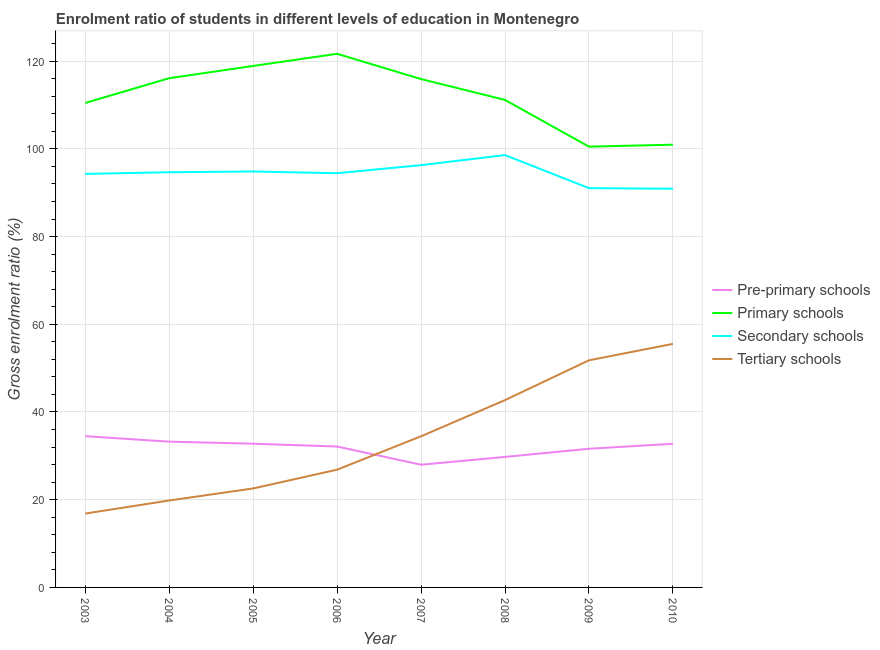How many different coloured lines are there?
Give a very brief answer. 4. Is the number of lines equal to the number of legend labels?
Your answer should be compact. Yes. What is the gross enrolment ratio in secondary schools in 2005?
Give a very brief answer. 94.84. Across all years, what is the maximum gross enrolment ratio in primary schools?
Keep it short and to the point. 121.67. Across all years, what is the minimum gross enrolment ratio in pre-primary schools?
Keep it short and to the point. 27.98. What is the total gross enrolment ratio in tertiary schools in the graph?
Offer a terse response. 270.57. What is the difference between the gross enrolment ratio in secondary schools in 2006 and that in 2007?
Provide a short and direct response. -1.85. What is the difference between the gross enrolment ratio in tertiary schools in 2009 and the gross enrolment ratio in secondary schools in 2003?
Your answer should be compact. -42.5. What is the average gross enrolment ratio in pre-primary schools per year?
Give a very brief answer. 31.84. In the year 2006, what is the difference between the gross enrolment ratio in tertiary schools and gross enrolment ratio in pre-primary schools?
Your answer should be compact. -5.28. In how many years, is the gross enrolment ratio in pre-primary schools greater than 108 %?
Your answer should be very brief. 0. What is the ratio of the gross enrolment ratio in primary schools in 2004 to that in 2005?
Give a very brief answer. 0.98. Is the difference between the gross enrolment ratio in pre-primary schools in 2003 and 2010 greater than the difference between the gross enrolment ratio in secondary schools in 2003 and 2010?
Your answer should be very brief. No. What is the difference between the highest and the second highest gross enrolment ratio in tertiary schools?
Your response must be concise. 3.75. What is the difference between the highest and the lowest gross enrolment ratio in primary schools?
Ensure brevity in your answer.  21.16. Is the sum of the gross enrolment ratio in tertiary schools in 2007 and 2010 greater than the maximum gross enrolment ratio in secondary schools across all years?
Keep it short and to the point. No. Does the gross enrolment ratio in pre-primary schools monotonically increase over the years?
Offer a terse response. No. Is the gross enrolment ratio in primary schools strictly less than the gross enrolment ratio in tertiary schools over the years?
Make the answer very short. No. How many lines are there?
Provide a short and direct response. 4. How many years are there in the graph?
Your answer should be compact. 8. Are the values on the major ticks of Y-axis written in scientific E-notation?
Your response must be concise. No. Does the graph contain grids?
Offer a very short reply. Yes. Where does the legend appear in the graph?
Your answer should be very brief. Center right. How many legend labels are there?
Ensure brevity in your answer.  4. What is the title of the graph?
Provide a succinct answer. Enrolment ratio of students in different levels of education in Montenegro. Does "France" appear as one of the legend labels in the graph?
Your answer should be very brief. No. What is the label or title of the X-axis?
Your answer should be very brief. Year. What is the Gross enrolment ratio (%) in Pre-primary schools in 2003?
Offer a very short reply. 34.48. What is the Gross enrolment ratio (%) of Primary schools in 2003?
Keep it short and to the point. 110.46. What is the Gross enrolment ratio (%) of Secondary schools in 2003?
Your answer should be compact. 94.29. What is the Gross enrolment ratio (%) of Tertiary schools in 2003?
Your response must be concise. 16.84. What is the Gross enrolment ratio (%) of Pre-primary schools in 2004?
Your answer should be very brief. 33.24. What is the Gross enrolment ratio (%) in Primary schools in 2004?
Ensure brevity in your answer.  116.11. What is the Gross enrolment ratio (%) of Secondary schools in 2004?
Keep it short and to the point. 94.66. What is the Gross enrolment ratio (%) of Tertiary schools in 2004?
Ensure brevity in your answer.  19.82. What is the Gross enrolment ratio (%) in Pre-primary schools in 2005?
Offer a very short reply. 32.77. What is the Gross enrolment ratio (%) of Primary schools in 2005?
Keep it short and to the point. 118.9. What is the Gross enrolment ratio (%) in Secondary schools in 2005?
Your answer should be very brief. 94.84. What is the Gross enrolment ratio (%) of Tertiary schools in 2005?
Your answer should be very brief. 22.57. What is the Gross enrolment ratio (%) in Pre-primary schools in 2006?
Keep it short and to the point. 32.13. What is the Gross enrolment ratio (%) in Primary schools in 2006?
Provide a succinct answer. 121.67. What is the Gross enrolment ratio (%) of Secondary schools in 2006?
Your answer should be very brief. 94.44. What is the Gross enrolment ratio (%) of Tertiary schools in 2006?
Your answer should be compact. 26.85. What is the Gross enrolment ratio (%) in Pre-primary schools in 2007?
Offer a very short reply. 27.98. What is the Gross enrolment ratio (%) in Primary schools in 2007?
Keep it short and to the point. 115.91. What is the Gross enrolment ratio (%) in Secondary schools in 2007?
Provide a succinct answer. 96.29. What is the Gross enrolment ratio (%) of Tertiary schools in 2007?
Your answer should be very brief. 34.46. What is the Gross enrolment ratio (%) of Pre-primary schools in 2008?
Ensure brevity in your answer.  29.76. What is the Gross enrolment ratio (%) of Primary schools in 2008?
Make the answer very short. 111.16. What is the Gross enrolment ratio (%) of Secondary schools in 2008?
Keep it short and to the point. 98.57. What is the Gross enrolment ratio (%) in Tertiary schools in 2008?
Your answer should be compact. 42.71. What is the Gross enrolment ratio (%) in Pre-primary schools in 2009?
Provide a short and direct response. 31.62. What is the Gross enrolment ratio (%) in Primary schools in 2009?
Make the answer very short. 100.5. What is the Gross enrolment ratio (%) of Secondary schools in 2009?
Give a very brief answer. 91.04. What is the Gross enrolment ratio (%) in Tertiary schools in 2009?
Give a very brief answer. 51.79. What is the Gross enrolment ratio (%) of Pre-primary schools in 2010?
Your response must be concise. 32.75. What is the Gross enrolment ratio (%) of Primary schools in 2010?
Provide a short and direct response. 100.95. What is the Gross enrolment ratio (%) of Secondary schools in 2010?
Offer a very short reply. 90.9. What is the Gross enrolment ratio (%) in Tertiary schools in 2010?
Offer a very short reply. 55.53. Across all years, what is the maximum Gross enrolment ratio (%) in Pre-primary schools?
Give a very brief answer. 34.48. Across all years, what is the maximum Gross enrolment ratio (%) in Primary schools?
Make the answer very short. 121.67. Across all years, what is the maximum Gross enrolment ratio (%) of Secondary schools?
Offer a terse response. 98.57. Across all years, what is the maximum Gross enrolment ratio (%) in Tertiary schools?
Offer a very short reply. 55.53. Across all years, what is the minimum Gross enrolment ratio (%) in Pre-primary schools?
Offer a very short reply. 27.98. Across all years, what is the minimum Gross enrolment ratio (%) of Primary schools?
Your response must be concise. 100.5. Across all years, what is the minimum Gross enrolment ratio (%) of Secondary schools?
Your response must be concise. 90.9. Across all years, what is the minimum Gross enrolment ratio (%) in Tertiary schools?
Your response must be concise. 16.84. What is the total Gross enrolment ratio (%) in Pre-primary schools in the graph?
Your answer should be compact. 254.72. What is the total Gross enrolment ratio (%) of Primary schools in the graph?
Your answer should be compact. 895.66. What is the total Gross enrolment ratio (%) in Secondary schools in the graph?
Offer a very short reply. 755.04. What is the total Gross enrolment ratio (%) of Tertiary schools in the graph?
Keep it short and to the point. 270.57. What is the difference between the Gross enrolment ratio (%) in Pre-primary schools in 2003 and that in 2004?
Your response must be concise. 1.25. What is the difference between the Gross enrolment ratio (%) in Primary schools in 2003 and that in 2004?
Your response must be concise. -5.64. What is the difference between the Gross enrolment ratio (%) in Secondary schools in 2003 and that in 2004?
Ensure brevity in your answer.  -0.38. What is the difference between the Gross enrolment ratio (%) of Tertiary schools in 2003 and that in 2004?
Your answer should be compact. -2.98. What is the difference between the Gross enrolment ratio (%) of Pre-primary schools in 2003 and that in 2005?
Your answer should be compact. 1.71. What is the difference between the Gross enrolment ratio (%) of Primary schools in 2003 and that in 2005?
Your answer should be compact. -8.44. What is the difference between the Gross enrolment ratio (%) of Secondary schools in 2003 and that in 2005?
Your answer should be very brief. -0.55. What is the difference between the Gross enrolment ratio (%) in Tertiary schools in 2003 and that in 2005?
Your answer should be very brief. -5.73. What is the difference between the Gross enrolment ratio (%) of Pre-primary schools in 2003 and that in 2006?
Ensure brevity in your answer.  2.36. What is the difference between the Gross enrolment ratio (%) in Primary schools in 2003 and that in 2006?
Provide a succinct answer. -11.2. What is the difference between the Gross enrolment ratio (%) in Secondary schools in 2003 and that in 2006?
Offer a terse response. -0.15. What is the difference between the Gross enrolment ratio (%) of Tertiary schools in 2003 and that in 2006?
Your answer should be very brief. -10.01. What is the difference between the Gross enrolment ratio (%) of Pre-primary schools in 2003 and that in 2007?
Provide a short and direct response. 6.51. What is the difference between the Gross enrolment ratio (%) of Primary schools in 2003 and that in 2007?
Provide a short and direct response. -5.45. What is the difference between the Gross enrolment ratio (%) of Secondary schools in 2003 and that in 2007?
Keep it short and to the point. -2. What is the difference between the Gross enrolment ratio (%) of Tertiary schools in 2003 and that in 2007?
Provide a short and direct response. -17.62. What is the difference between the Gross enrolment ratio (%) of Pre-primary schools in 2003 and that in 2008?
Your answer should be very brief. 4.73. What is the difference between the Gross enrolment ratio (%) in Primary schools in 2003 and that in 2008?
Ensure brevity in your answer.  -0.69. What is the difference between the Gross enrolment ratio (%) of Secondary schools in 2003 and that in 2008?
Keep it short and to the point. -4.28. What is the difference between the Gross enrolment ratio (%) in Tertiary schools in 2003 and that in 2008?
Your answer should be very brief. -25.87. What is the difference between the Gross enrolment ratio (%) of Pre-primary schools in 2003 and that in 2009?
Offer a terse response. 2.87. What is the difference between the Gross enrolment ratio (%) in Primary schools in 2003 and that in 2009?
Ensure brevity in your answer.  9.96. What is the difference between the Gross enrolment ratio (%) in Secondary schools in 2003 and that in 2009?
Your answer should be compact. 3.25. What is the difference between the Gross enrolment ratio (%) in Tertiary schools in 2003 and that in 2009?
Provide a succinct answer. -34.94. What is the difference between the Gross enrolment ratio (%) in Pre-primary schools in 2003 and that in 2010?
Make the answer very short. 1.73. What is the difference between the Gross enrolment ratio (%) of Primary schools in 2003 and that in 2010?
Give a very brief answer. 9.52. What is the difference between the Gross enrolment ratio (%) of Secondary schools in 2003 and that in 2010?
Offer a terse response. 3.39. What is the difference between the Gross enrolment ratio (%) in Tertiary schools in 2003 and that in 2010?
Your answer should be very brief. -38.69. What is the difference between the Gross enrolment ratio (%) in Pre-primary schools in 2004 and that in 2005?
Your response must be concise. 0.47. What is the difference between the Gross enrolment ratio (%) of Primary schools in 2004 and that in 2005?
Provide a succinct answer. -2.8. What is the difference between the Gross enrolment ratio (%) in Secondary schools in 2004 and that in 2005?
Give a very brief answer. -0.18. What is the difference between the Gross enrolment ratio (%) in Tertiary schools in 2004 and that in 2005?
Your response must be concise. -2.75. What is the difference between the Gross enrolment ratio (%) of Pre-primary schools in 2004 and that in 2006?
Offer a very short reply. 1.11. What is the difference between the Gross enrolment ratio (%) of Primary schools in 2004 and that in 2006?
Ensure brevity in your answer.  -5.56. What is the difference between the Gross enrolment ratio (%) in Secondary schools in 2004 and that in 2006?
Your answer should be very brief. 0.22. What is the difference between the Gross enrolment ratio (%) in Tertiary schools in 2004 and that in 2006?
Give a very brief answer. -7.03. What is the difference between the Gross enrolment ratio (%) in Pre-primary schools in 2004 and that in 2007?
Provide a short and direct response. 5.26. What is the difference between the Gross enrolment ratio (%) in Primary schools in 2004 and that in 2007?
Offer a very short reply. 0.19. What is the difference between the Gross enrolment ratio (%) of Secondary schools in 2004 and that in 2007?
Make the answer very short. -1.62. What is the difference between the Gross enrolment ratio (%) of Tertiary schools in 2004 and that in 2007?
Keep it short and to the point. -14.64. What is the difference between the Gross enrolment ratio (%) in Pre-primary schools in 2004 and that in 2008?
Your answer should be compact. 3.48. What is the difference between the Gross enrolment ratio (%) in Primary schools in 2004 and that in 2008?
Keep it short and to the point. 4.95. What is the difference between the Gross enrolment ratio (%) of Secondary schools in 2004 and that in 2008?
Keep it short and to the point. -3.91. What is the difference between the Gross enrolment ratio (%) in Tertiary schools in 2004 and that in 2008?
Your answer should be very brief. -22.89. What is the difference between the Gross enrolment ratio (%) in Pre-primary schools in 2004 and that in 2009?
Your answer should be compact. 1.62. What is the difference between the Gross enrolment ratio (%) of Primary schools in 2004 and that in 2009?
Provide a short and direct response. 15.6. What is the difference between the Gross enrolment ratio (%) in Secondary schools in 2004 and that in 2009?
Keep it short and to the point. 3.62. What is the difference between the Gross enrolment ratio (%) in Tertiary schools in 2004 and that in 2009?
Your answer should be very brief. -31.97. What is the difference between the Gross enrolment ratio (%) of Pre-primary schools in 2004 and that in 2010?
Offer a terse response. 0.49. What is the difference between the Gross enrolment ratio (%) in Primary schools in 2004 and that in 2010?
Offer a terse response. 15.16. What is the difference between the Gross enrolment ratio (%) of Secondary schools in 2004 and that in 2010?
Your response must be concise. 3.76. What is the difference between the Gross enrolment ratio (%) in Tertiary schools in 2004 and that in 2010?
Provide a succinct answer. -35.71. What is the difference between the Gross enrolment ratio (%) of Pre-primary schools in 2005 and that in 2006?
Provide a short and direct response. 0.64. What is the difference between the Gross enrolment ratio (%) of Primary schools in 2005 and that in 2006?
Offer a very short reply. -2.76. What is the difference between the Gross enrolment ratio (%) of Secondary schools in 2005 and that in 2006?
Make the answer very short. 0.4. What is the difference between the Gross enrolment ratio (%) in Tertiary schools in 2005 and that in 2006?
Make the answer very short. -4.28. What is the difference between the Gross enrolment ratio (%) in Pre-primary schools in 2005 and that in 2007?
Provide a short and direct response. 4.79. What is the difference between the Gross enrolment ratio (%) in Primary schools in 2005 and that in 2007?
Give a very brief answer. 2.99. What is the difference between the Gross enrolment ratio (%) of Secondary schools in 2005 and that in 2007?
Make the answer very short. -1.45. What is the difference between the Gross enrolment ratio (%) of Tertiary schools in 2005 and that in 2007?
Provide a succinct answer. -11.89. What is the difference between the Gross enrolment ratio (%) of Pre-primary schools in 2005 and that in 2008?
Your answer should be compact. 3.01. What is the difference between the Gross enrolment ratio (%) in Primary schools in 2005 and that in 2008?
Provide a succinct answer. 7.75. What is the difference between the Gross enrolment ratio (%) of Secondary schools in 2005 and that in 2008?
Your answer should be very brief. -3.73. What is the difference between the Gross enrolment ratio (%) of Tertiary schools in 2005 and that in 2008?
Ensure brevity in your answer.  -20.14. What is the difference between the Gross enrolment ratio (%) of Pre-primary schools in 2005 and that in 2009?
Provide a succinct answer. 1.15. What is the difference between the Gross enrolment ratio (%) of Primary schools in 2005 and that in 2009?
Your answer should be compact. 18.4. What is the difference between the Gross enrolment ratio (%) of Secondary schools in 2005 and that in 2009?
Ensure brevity in your answer.  3.8. What is the difference between the Gross enrolment ratio (%) in Tertiary schools in 2005 and that in 2009?
Offer a very short reply. -29.22. What is the difference between the Gross enrolment ratio (%) in Pre-primary schools in 2005 and that in 2010?
Your answer should be very brief. 0.02. What is the difference between the Gross enrolment ratio (%) in Primary schools in 2005 and that in 2010?
Your answer should be compact. 17.96. What is the difference between the Gross enrolment ratio (%) in Secondary schools in 2005 and that in 2010?
Keep it short and to the point. 3.94. What is the difference between the Gross enrolment ratio (%) of Tertiary schools in 2005 and that in 2010?
Your answer should be compact. -32.96. What is the difference between the Gross enrolment ratio (%) in Pre-primary schools in 2006 and that in 2007?
Provide a succinct answer. 4.15. What is the difference between the Gross enrolment ratio (%) in Primary schools in 2006 and that in 2007?
Offer a very short reply. 5.76. What is the difference between the Gross enrolment ratio (%) in Secondary schools in 2006 and that in 2007?
Offer a terse response. -1.85. What is the difference between the Gross enrolment ratio (%) of Tertiary schools in 2006 and that in 2007?
Provide a short and direct response. -7.62. What is the difference between the Gross enrolment ratio (%) of Pre-primary schools in 2006 and that in 2008?
Offer a terse response. 2.37. What is the difference between the Gross enrolment ratio (%) of Primary schools in 2006 and that in 2008?
Provide a succinct answer. 10.51. What is the difference between the Gross enrolment ratio (%) of Secondary schools in 2006 and that in 2008?
Offer a terse response. -4.13. What is the difference between the Gross enrolment ratio (%) in Tertiary schools in 2006 and that in 2008?
Keep it short and to the point. -15.86. What is the difference between the Gross enrolment ratio (%) in Pre-primary schools in 2006 and that in 2009?
Your answer should be very brief. 0.51. What is the difference between the Gross enrolment ratio (%) of Primary schools in 2006 and that in 2009?
Provide a short and direct response. 21.16. What is the difference between the Gross enrolment ratio (%) of Secondary schools in 2006 and that in 2009?
Your response must be concise. 3.4. What is the difference between the Gross enrolment ratio (%) in Tertiary schools in 2006 and that in 2009?
Offer a very short reply. -24.94. What is the difference between the Gross enrolment ratio (%) in Pre-primary schools in 2006 and that in 2010?
Your response must be concise. -0.62. What is the difference between the Gross enrolment ratio (%) in Primary schools in 2006 and that in 2010?
Give a very brief answer. 20.72. What is the difference between the Gross enrolment ratio (%) in Secondary schools in 2006 and that in 2010?
Provide a succinct answer. 3.54. What is the difference between the Gross enrolment ratio (%) in Tertiary schools in 2006 and that in 2010?
Your answer should be compact. -28.68. What is the difference between the Gross enrolment ratio (%) in Pre-primary schools in 2007 and that in 2008?
Make the answer very short. -1.78. What is the difference between the Gross enrolment ratio (%) in Primary schools in 2007 and that in 2008?
Your answer should be compact. 4.76. What is the difference between the Gross enrolment ratio (%) of Secondary schools in 2007 and that in 2008?
Offer a terse response. -2.28. What is the difference between the Gross enrolment ratio (%) in Tertiary schools in 2007 and that in 2008?
Your answer should be very brief. -8.25. What is the difference between the Gross enrolment ratio (%) of Pre-primary schools in 2007 and that in 2009?
Offer a terse response. -3.64. What is the difference between the Gross enrolment ratio (%) of Primary schools in 2007 and that in 2009?
Offer a very short reply. 15.41. What is the difference between the Gross enrolment ratio (%) of Secondary schools in 2007 and that in 2009?
Your answer should be very brief. 5.25. What is the difference between the Gross enrolment ratio (%) of Tertiary schools in 2007 and that in 2009?
Keep it short and to the point. -17.32. What is the difference between the Gross enrolment ratio (%) in Pre-primary schools in 2007 and that in 2010?
Offer a very short reply. -4.77. What is the difference between the Gross enrolment ratio (%) in Primary schools in 2007 and that in 2010?
Your response must be concise. 14.96. What is the difference between the Gross enrolment ratio (%) of Secondary schools in 2007 and that in 2010?
Your answer should be very brief. 5.39. What is the difference between the Gross enrolment ratio (%) in Tertiary schools in 2007 and that in 2010?
Ensure brevity in your answer.  -21.07. What is the difference between the Gross enrolment ratio (%) in Pre-primary schools in 2008 and that in 2009?
Ensure brevity in your answer.  -1.86. What is the difference between the Gross enrolment ratio (%) of Primary schools in 2008 and that in 2009?
Provide a succinct answer. 10.65. What is the difference between the Gross enrolment ratio (%) in Secondary schools in 2008 and that in 2009?
Your answer should be compact. 7.53. What is the difference between the Gross enrolment ratio (%) of Tertiary schools in 2008 and that in 2009?
Make the answer very short. -9.08. What is the difference between the Gross enrolment ratio (%) of Pre-primary schools in 2008 and that in 2010?
Offer a terse response. -2.99. What is the difference between the Gross enrolment ratio (%) of Primary schools in 2008 and that in 2010?
Your answer should be very brief. 10.21. What is the difference between the Gross enrolment ratio (%) of Secondary schools in 2008 and that in 2010?
Offer a terse response. 7.67. What is the difference between the Gross enrolment ratio (%) of Tertiary schools in 2008 and that in 2010?
Your response must be concise. -12.82. What is the difference between the Gross enrolment ratio (%) in Pre-primary schools in 2009 and that in 2010?
Your answer should be compact. -1.13. What is the difference between the Gross enrolment ratio (%) in Primary schools in 2009 and that in 2010?
Keep it short and to the point. -0.44. What is the difference between the Gross enrolment ratio (%) of Secondary schools in 2009 and that in 2010?
Provide a succinct answer. 0.14. What is the difference between the Gross enrolment ratio (%) of Tertiary schools in 2009 and that in 2010?
Your answer should be compact. -3.75. What is the difference between the Gross enrolment ratio (%) of Pre-primary schools in 2003 and the Gross enrolment ratio (%) of Primary schools in 2004?
Give a very brief answer. -81.62. What is the difference between the Gross enrolment ratio (%) of Pre-primary schools in 2003 and the Gross enrolment ratio (%) of Secondary schools in 2004?
Provide a succinct answer. -60.18. What is the difference between the Gross enrolment ratio (%) in Pre-primary schools in 2003 and the Gross enrolment ratio (%) in Tertiary schools in 2004?
Give a very brief answer. 14.67. What is the difference between the Gross enrolment ratio (%) of Primary schools in 2003 and the Gross enrolment ratio (%) of Secondary schools in 2004?
Offer a terse response. 15.8. What is the difference between the Gross enrolment ratio (%) of Primary schools in 2003 and the Gross enrolment ratio (%) of Tertiary schools in 2004?
Provide a short and direct response. 90.65. What is the difference between the Gross enrolment ratio (%) in Secondary schools in 2003 and the Gross enrolment ratio (%) in Tertiary schools in 2004?
Your response must be concise. 74.47. What is the difference between the Gross enrolment ratio (%) in Pre-primary schools in 2003 and the Gross enrolment ratio (%) in Primary schools in 2005?
Provide a short and direct response. -84.42. What is the difference between the Gross enrolment ratio (%) in Pre-primary schools in 2003 and the Gross enrolment ratio (%) in Secondary schools in 2005?
Make the answer very short. -60.36. What is the difference between the Gross enrolment ratio (%) in Pre-primary schools in 2003 and the Gross enrolment ratio (%) in Tertiary schools in 2005?
Your answer should be very brief. 11.91. What is the difference between the Gross enrolment ratio (%) of Primary schools in 2003 and the Gross enrolment ratio (%) of Secondary schools in 2005?
Provide a succinct answer. 15.62. What is the difference between the Gross enrolment ratio (%) of Primary schools in 2003 and the Gross enrolment ratio (%) of Tertiary schools in 2005?
Provide a succinct answer. 87.89. What is the difference between the Gross enrolment ratio (%) of Secondary schools in 2003 and the Gross enrolment ratio (%) of Tertiary schools in 2005?
Provide a short and direct response. 71.72. What is the difference between the Gross enrolment ratio (%) in Pre-primary schools in 2003 and the Gross enrolment ratio (%) in Primary schools in 2006?
Offer a very short reply. -87.18. What is the difference between the Gross enrolment ratio (%) in Pre-primary schools in 2003 and the Gross enrolment ratio (%) in Secondary schools in 2006?
Your answer should be very brief. -59.96. What is the difference between the Gross enrolment ratio (%) of Pre-primary schools in 2003 and the Gross enrolment ratio (%) of Tertiary schools in 2006?
Your answer should be compact. 7.64. What is the difference between the Gross enrolment ratio (%) in Primary schools in 2003 and the Gross enrolment ratio (%) in Secondary schools in 2006?
Offer a terse response. 16.02. What is the difference between the Gross enrolment ratio (%) of Primary schools in 2003 and the Gross enrolment ratio (%) of Tertiary schools in 2006?
Your answer should be very brief. 83.62. What is the difference between the Gross enrolment ratio (%) of Secondary schools in 2003 and the Gross enrolment ratio (%) of Tertiary schools in 2006?
Offer a terse response. 67.44. What is the difference between the Gross enrolment ratio (%) in Pre-primary schools in 2003 and the Gross enrolment ratio (%) in Primary schools in 2007?
Provide a short and direct response. -81.43. What is the difference between the Gross enrolment ratio (%) of Pre-primary schools in 2003 and the Gross enrolment ratio (%) of Secondary schools in 2007?
Provide a short and direct response. -61.8. What is the difference between the Gross enrolment ratio (%) of Pre-primary schools in 2003 and the Gross enrolment ratio (%) of Tertiary schools in 2007?
Your answer should be very brief. 0.02. What is the difference between the Gross enrolment ratio (%) in Primary schools in 2003 and the Gross enrolment ratio (%) in Secondary schools in 2007?
Offer a very short reply. 14.18. What is the difference between the Gross enrolment ratio (%) in Primary schools in 2003 and the Gross enrolment ratio (%) in Tertiary schools in 2007?
Provide a succinct answer. 76. What is the difference between the Gross enrolment ratio (%) of Secondary schools in 2003 and the Gross enrolment ratio (%) of Tertiary schools in 2007?
Make the answer very short. 59.83. What is the difference between the Gross enrolment ratio (%) of Pre-primary schools in 2003 and the Gross enrolment ratio (%) of Primary schools in 2008?
Make the answer very short. -76.67. What is the difference between the Gross enrolment ratio (%) in Pre-primary schools in 2003 and the Gross enrolment ratio (%) in Secondary schools in 2008?
Provide a short and direct response. -64.09. What is the difference between the Gross enrolment ratio (%) in Pre-primary schools in 2003 and the Gross enrolment ratio (%) in Tertiary schools in 2008?
Provide a succinct answer. -8.23. What is the difference between the Gross enrolment ratio (%) of Primary schools in 2003 and the Gross enrolment ratio (%) of Secondary schools in 2008?
Make the answer very short. 11.89. What is the difference between the Gross enrolment ratio (%) in Primary schools in 2003 and the Gross enrolment ratio (%) in Tertiary schools in 2008?
Provide a short and direct response. 67.75. What is the difference between the Gross enrolment ratio (%) in Secondary schools in 2003 and the Gross enrolment ratio (%) in Tertiary schools in 2008?
Your response must be concise. 51.58. What is the difference between the Gross enrolment ratio (%) in Pre-primary schools in 2003 and the Gross enrolment ratio (%) in Primary schools in 2009?
Make the answer very short. -66.02. What is the difference between the Gross enrolment ratio (%) in Pre-primary schools in 2003 and the Gross enrolment ratio (%) in Secondary schools in 2009?
Offer a terse response. -56.56. What is the difference between the Gross enrolment ratio (%) in Pre-primary schools in 2003 and the Gross enrolment ratio (%) in Tertiary schools in 2009?
Your response must be concise. -17.3. What is the difference between the Gross enrolment ratio (%) of Primary schools in 2003 and the Gross enrolment ratio (%) of Secondary schools in 2009?
Your response must be concise. 19.42. What is the difference between the Gross enrolment ratio (%) in Primary schools in 2003 and the Gross enrolment ratio (%) in Tertiary schools in 2009?
Your answer should be very brief. 58.68. What is the difference between the Gross enrolment ratio (%) of Secondary schools in 2003 and the Gross enrolment ratio (%) of Tertiary schools in 2009?
Offer a very short reply. 42.5. What is the difference between the Gross enrolment ratio (%) in Pre-primary schools in 2003 and the Gross enrolment ratio (%) in Primary schools in 2010?
Keep it short and to the point. -66.46. What is the difference between the Gross enrolment ratio (%) in Pre-primary schools in 2003 and the Gross enrolment ratio (%) in Secondary schools in 2010?
Give a very brief answer. -56.42. What is the difference between the Gross enrolment ratio (%) of Pre-primary schools in 2003 and the Gross enrolment ratio (%) of Tertiary schools in 2010?
Ensure brevity in your answer.  -21.05. What is the difference between the Gross enrolment ratio (%) in Primary schools in 2003 and the Gross enrolment ratio (%) in Secondary schools in 2010?
Your response must be concise. 19.56. What is the difference between the Gross enrolment ratio (%) of Primary schools in 2003 and the Gross enrolment ratio (%) of Tertiary schools in 2010?
Provide a succinct answer. 54.93. What is the difference between the Gross enrolment ratio (%) of Secondary schools in 2003 and the Gross enrolment ratio (%) of Tertiary schools in 2010?
Your answer should be compact. 38.76. What is the difference between the Gross enrolment ratio (%) of Pre-primary schools in 2004 and the Gross enrolment ratio (%) of Primary schools in 2005?
Provide a short and direct response. -85.67. What is the difference between the Gross enrolment ratio (%) of Pre-primary schools in 2004 and the Gross enrolment ratio (%) of Secondary schools in 2005?
Ensure brevity in your answer.  -61.6. What is the difference between the Gross enrolment ratio (%) in Pre-primary schools in 2004 and the Gross enrolment ratio (%) in Tertiary schools in 2005?
Keep it short and to the point. 10.67. What is the difference between the Gross enrolment ratio (%) in Primary schools in 2004 and the Gross enrolment ratio (%) in Secondary schools in 2005?
Offer a very short reply. 21.27. What is the difference between the Gross enrolment ratio (%) of Primary schools in 2004 and the Gross enrolment ratio (%) of Tertiary schools in 2005?
Ensure brevity in your answer.  93.54. What is the difference between the Gross enrolment ratio (%) of Secondary schools in 2004 and the Gross enrolment ratio (%) of Tertiary schools in 2005?
Provide a short and direct response. 72.09. What is the difference between the Gross enrolment ratio (%) in Pre-primary schools in 2004 and the Gross enrolment ratio (%) in Primary schools in 2006?
Provide a succinct answer. -88.43. What is the difference between the Gross enrolment ratio (%) of Pre-primary schools in 2004 and the Gross enrolment ratio (%) of Secondary schools in 2006?
Offer a very short reply. -61.2. What is the difference between the Gross enrolment ratio (%) in Pre-primary schools in 2004 and the Gross enrolment ratio (%) in Tertiary schools in 2006?
Provide a succinct answer. 6.39. What is the difference between the Gross enrolment ratio (%) in Primary schools in 2004 and the Gross enrolment ratio (%) in Secondary schools in 2006?
Provide a succinct answer. 21.66. What is the difference between the Gross enrolment ratio (%) in Primary schools in 2004 and the Gross enrolment ratio (%) in Tertiary schools in 2006?
Offer a very short reply. 89.26. What is the difference between the Gross enrolment ratio (%) in Secondary schools in 2004 and the Gross enrolment ratio (%) in Tertiary schools in 2006?
Keep it short and to the point. 67.82. What is the difference between the Gross enrolment ratio (%) in Pre-primary schools in 2004 and the Gross enrolment ratio (%) in Primary schools in 2007?
Keep it short and to the point. -82.67. What is the difference between the Gross enrolment ratio (%) of Pre-primary schools in 2004 and the Gross enrolment ratio (%) of Secondary schools in 2007?
Ensure brevity in your answer.  -63.05. What is the difference between the Gross enrolment ratio (%) of Pre-primary schools in 2004 and the Gross enrolment ratio (%) of Tertiary schools in 2007?
Your answer should be very brief. -1.22. What is the difference between the Gross enrolment ratio (%) in Primary schools in 2004 and the Gross enrolment ratio (%) in Secondary schools in 2007?
Provide a short and direct response. 19.82. What is the difference between the Gross enrolment ratio (%) in Primary schools in 2004 and the Gross enrolment ratio (%) in Tertiary schools in 2007?
Provide a succinct answer. 81.64. What is the difference between the Gross enrolment ratio (%) of Secondary schools in 2004 and the Gross enrolment ratio (%) of Tertiary schools in 2007?
Offer a terse response. 60.2. What is the difference between the Gross enrolment ratio (%) of Pre-primary schools in 2004 and the Gross enrolment ratio (%) of Primary schools in 2008?
Your response must be concise. -77.92. What is the difference between the Gross enrolment ratio (%) of Pre-primary schools in 2004 and the Gross enrolment ratio (%) of Secondary schools in 2008?
Your answer should be compact. -65.33. What is the difference between the Gross enrolment ratio (%) of Pre-primary schools in 2004 and the Gross enrolment ratio (%) of Tertiary schools in 2008?
Offer a very short reply. -9.47. What is the difference between the Gross enrolment ratio (%) in Primary schools in 2004 and the Gross enrolment ratio (%) in Secondary schools in 2008?
Keep it short and to the point. 17.53. What is the difference between the Gross enrolment ratio (%) in Primary schools in 2004 and the Gross enrolment ratio (%) in Tertiary schools in 2008?
Offer a terse response. 73.4. What is the difference between the Gross enrolment ratio (%) in Secondary schools in 2004 and the Gross enrolment ratio (%) in Tertiary schools in 2008?
Ensure brevity in your answer.  51.95. What is the difference between the Gross enrolment ratio (%) in Pre-primary schools in 2004 and the Gross enrolment ratio (%) in Primary schools in 2009?
Your response must be concise. -67.26. What is the difference between the Gross enrolment ratio (%) in Pre-primary schools in 2004 and the Gross enrolment ratio (%) in Secondary schools in 2009?
Provide a succinct answer. -57.8. What is the difference between the Gross enrolment ratio (%) of Pre-primary schools in 2004 and the Gross enrolment ratio (%) of Tertiary schools in 2009?
Provide a short and direct response. -18.55. What is the difference between the Gross enrolment ratio (%) in Primary schools in 2004 and the Gross enrolment ratio (%) in Secondary schools in 2009?
Offer a very short reply. 25.07. What is the difference between the Gross enrolment ratio (%) in Primary schools in 2004 and the Gross enrolment ratio (%) in Tertiary schools in 2009?
Make the answer very short. 64.32. What is the difference between the Gross enrolment ratio (%) of Secondary schools in 2004 and the Gross enrolment ratio (%) of Tertiary schools in 2009?
Provide a succinct answer. 42.88. What is the difference between the Gross enrolment ratio (%) of Pre-primary schools in 2004 and the Gross enrolment ratio (%) of Primary schools in 2010?
Provide a short and direct response. -67.71. What is the difference between the Gross enrolment ratio (%) in Pre-primary schools in 2004 and the Gross enrolment ratio (%) in Secondary schools in 2010?
Keep it short and to the point. -57.66. What is the difference between the Gross enrolment ratio (%) in Pre-primary schools in 2004 and the Gross enrolment ratio (%) in Tertiary schools in 2010?
Your answer should be compact. -22.29. What is the difference between the Gross enrolment ratio (%) in Primary schools in 2004 and the Gross enrolment ratio (%) in Secondary schools in 2010?
Give a very brief answer. 25.2. What is the difference between the Gross enrolment ratio (%) in Primary schools in 2004 and the Gross enrolment ratio (%) in Tertiary schools in 2010?
Your answer should be compact. 60.57. What is the difference between the Gross enrolment ratio (%) of Secondary schools in 2004 and the Gross enrolment ratio (%) of Tertiary schools in 2010?
Keep it short and to the point. 39.13. What is the difference between the Gross enrolment ratio (%) of Pre-primary schools in 2005 and the Gross enrolment ratio (%) of Primary schools in 2006?
Offer a very short reply. -88.9. What is the difference between the Gross enrolment ratio (%) in Pre-primary schools in 2005 and the Gross enrolment ratio (%) in Secondary schools in 2006?
Your answer should be very brief. -61.67. What is the difference between the Gross enrolment ratio (%) of Pre-primary schools in 2005 and the Gross enrolment ratio (%) of Tertiary schools in 2006?
Provide a short and direct response. 5.92. What is the difference between the Gross enrolment ratio (%) in Primary schools in 2005 and the Gross enrolment ratio (%) in Secondary schools in 2006?
Provide a short and direct response. 24.46. What is the difference between the Gross enrolment ratio (%) of Primary schools in 2005 and the Gross enrolment ratio (%) of Tertiary schools in 2006?
Your answer should be compact. 92.06. What is the difference between the Gross enrolment ratio (%) in Secondary schools in 2005 and the Gross enrolment ratio (%) in Tertiary schools in 2006?
Provide a short and direct response. 67.99. What is the difference between the Gross enrolment ratio (%) in Pre-primary schools in 2005 and the Gross enrolment ratio (%) in Primary schools in 2007?
Offer a very short reply. -83.14. What is the difference between the Gross enrolment ratio (%) of Pre-primary schools in 2005 and the Gross enrolment ratio (%) of Secondary schools in 2007?
Ensure brevity in your answer.  -63.52. What is the difference between the Gross enrolment ratio (%) of Pre-primary schools in 2005 and the Gross enrolment ratio (%) of Tertiary schools in 2007?
Provide a succinct answer. -1.69. What is the difference between the Gross enrolment ratio (%) in Primary schools in 2005 and the Gross enrolment ratio (%) in Secondary schools in 2007?
Offer a terse response. 22.62. What is the difference between the Gross enrolment ratio (%) in Primary schools in 2005 and the Gross enrolment ratio (%) in Tertiary schools in 2007?
Provide a short and direct response. 84.44. What is the difference between the Gross enrolment ratio (%) in Secondary schools in 2005 and the Gross enrolment ratio (%) in Tertiary schools in 2007?
Provide a short and direct response. 60.38. What is the difference between the Gross enrolment ratio (%) in Pre-primary schools in 2005 and the Gross enrolment ratio (%) in Primary schools in 2008?
Offer a terse response. -78.38. What is the difference between the Gross enrolment ratio (%) of Pre-primary schools in 2005 and the Gross enrolment ratio (%) of Secondary schools in 2008?
Make the answer very short. -65.8. What is the difference between the Gross enrolment ratio (%) in Pre-primary schools in 2005 and the Gross enrolment ratio (%) in Tertiary schools in 2008?
Keep it short and to the point. -9.94. What is the difference between the Gross enrolment ratio (%) in Primary schools in 2005 and the Gross enrolment ratio (%) in Secondary schools in 2008?
Your response must be concise. 20.33. What is the difference between the Gross enrolment ratio (%) of Primary schools in 2005 and the Gross enrolment ratio (%) of Tertiary schools in 2008?
Offer a very short reply. 76.19. What is the difference between the Gross enrolment ratio (%) of Secondary schools in 2005 and the Gross enrolment ratio (%) of Tertiary schools in 2008?
Offer a terse response. 52.13. What is the difference between the Gross enrolment ratio (%) of Pre-primary schools in 2005 and the Gross enrolment ratio (%) of Primary schools in 2009?
Keep it short and to the point. -67.73. What is the difference between the Gross enrolment ratio (%) of Pre-primary schools in 2005 and the Gross enrolment ratio (%) of Secondary schools in 2009?
Give a very brief answer. -58.27. What is the difference between the Gross enrolment ratio (%) of Pre-primary schools in 2005 and the Gross enrolment ratio (%) of Tertiary schools in 2009?
Give a very brief answer. -19.01. What is the difference between the Gross enrolment ratio (%) of Primary schools in 2005 and the Gross enrolment ratio (%) of Secondary schools in 2009?
Make the answer very short. 27.86. What is the difference between the Gross enrolment ratio (%) of Primary schools in 2005 and the Gross enrolment ratio (%) of Tertiary schools in 2009?
Your answer should be compact. 67.12. What is the difference between the Gross enrolment ratio (%) in Secondary schools in 2005 and the Gross enrolment ratio (%) in Tertiary schools in 2009?
Give a very brief answer. 43.06. What is the difference between the Gross enrolment ratio (%) of Pre-primary schools in 2005 and the Gross enrolment ratio (%) of Primary schools in 2010?
Your answer should be compact. -68.18. What is the difference between the Gross enrolment ratio (%) of Pre-primary schools in 2005 and the Gross enrolment ratio (%) of Secondary schools in 2010?
Provide a short and direct response. -58.13. What is the difference between the Gross enrolment ratio (%) of Pre-primary schools in 2005 and the Gross enrolment ratio (%) of Tertiary schools in 2010?
Make the answer very short. -22.76. What is the difference between the Gross enrolment ratio (%) of Primary schools in 2005 and the Gross enrolment ratio (%) of Secondary schools in 2010?
Ensure brevity in your answer.  28. What is the difference between the Gross enrolment ratio (%) of Primary schools in 2005 and the Gross enrolment ratio (%) of Tertiary schools in 2010?
Give a very brief answer. 63.37. What is the difference between the Gross enrolment ratio (%) in Secondary schools in 2005 and the Gross enrolment ratio (%) in Tertiary schools in 2010?
Your answer should be compact. 39.31. What is the difference between the Gross enrolment ratio (%) in Pre-primary schools in 2006 and the Gross enrolment ratio (%) in Primary schools in 2007?
Your response must be concise. -83.78. What is the difference between the Gross enrolment ratio (%) of Pre-primary schools in 2006 and the Gross enrolment ratio (%) of Secondary schools in 2007?
Ensure brevity in your answer.  -64.16. What is the difference between the Gross enrolment ratio (%) in Pre-primary schools in 2006 and the Gross enrolment ratio (%) in Tertiary schools in 2007?
Make the answer very short. -2.34. What is the difference between the Gross enrolment ratio (%) in Primary schools in 2006 and the Gross enrolment ratio (%) in Secondary schools in 2007?
Your response must be concise. 25.38. What is the difference between the Gross enrolment ratio (%) of Primary schools in 2006 and the Gross enrolment ratio (%) of Tertiary schools in 2007?
Provide a short and direct response. 87.21. What is the difference between the Gross enrolment ratio (%) in Secondary schools in 2006 and the Gross enrolment ratio (%) in Tertiary schools in 2007?
Provide a succinct answer. 59.98. What is the difference between the Gross enrolment ratio (%) in Pre-primary schools in 2006 and the Gross enrolment ratio (%) in Primary schools in 2008?
Provide a succinct answer. -79.03. What is the difference between the Gross enrolment ratio (%) of Pre-primary schools in 2006 and the Gross enrolment ratio (%) of Secondary schools in 2008?
Give a very brief answer. -66.44. What is the difference between the Gross enrolment ratio (%) of Pre-primary schools in 2006 and the Gross enrolment ratio (%) of Tertiary schools in 2008?
Provide a succinct answer. -10.58. What is the difference between the Gross enrolment ratio (%) in Primary schools in 2006 and the Gross enrolment ratio (%) in Secondary schools in 2008?
Your response must be concise. 23.1. What is the difference between the Gross enrolment ratio (%) of Primary schools in 2006 and the Gross enrolment ratio (%) of Tertiary schools in 2008?
Give a very brief answer. 78.96. What is the difference between the Gross enrolment ratio (%) in Secondary schools in 2006 and the Gross enrolment ratio (%) in Tertiary schools in 2008?
Offer a terse response. 51.73. What is the difference between the Gross enrolment ratio (%) in Pre-primary schools in 2006 and the Gross enrolment ratio (%) in Primary schools in 2009?
Your answer should be compact. -68.38. What is the difference between the Gross enrolment ratio (%) of Pre-primary schools in 2006 and the Gross enrolment ratio (%) of Secondary schools in 2009?
Give a very brief answer. -58.91. What is the difference between the Gross enrolment ratio (%) in Pre-primary schools in 2006 and the Gross enrolment ratio (%) in Tertiary schools in 2009?
Offer a very short reply. -19.66. What is the difference between the Gross enrolment ratio (%) in Primary schools in 2006 and the Gross enrolment ratio (%) in Secondary schools in 2009?
Ensure brevity in your answer.  30.63. What is the difference between the Gross enrolment ratio (%) in Primary schools in 2006 and the Gross enrolment ratio (%) in Tertiary schools in 2009?
Give a very brief answer. 69.88. What is the difference between the Gross enrolment ratio (%) of Secondary schools in 2006 and the Gross enrolment ratio (%) of Tertiary schools in 2009?
Give a very brief answer. 42.66. What is the difference between the Gross enrolment ratio (%) of Pre-primary schools in 2006 and the Gross enrolment ratio (%) of Primary schools in 2010?
Provide a short and direct response. -68.82. What is the difference between the Gross enrolment ratio (%) in Pre-primary schools in 2006 and the Gross enrolment ratio (%) in Secondary schools in 2010?
Your response must be concise. -58.78. What is the difference between the Gross enrolment ratio (%) in Pre-primary schools in 2006 and the Gross enrolment ratio (%) in Tertiary schools in 2010?
Give a very brief answer. -23.41. What is the difference between the Gross enrolment ratio (%) of Primary schools in 2006 and the Gross enrolment ratio (%) of Secondary schools in 2010?
Offer a very short reply. 30.77. What is the difference between the Gross enrolment ratio (%) of Primary schools in 2006 and the Gross enrolment ratio (%) of Tertiary schools in 2010?
Provide a succinct answer. 66.14. What is the difference between the Gross enrolment ratio (%) of Secondary schools in 2006 and the Gross enrolment ratio (%) of Tertiary schools in 2010?
Your response must be concise. 38.91. What is the difference between the Gross enrolment ratio (%) of Pre-primary schools in 2007 and the Gross enrolment ratio (%) of Primary schools in 2008?
Your response must be concise. -83.18. What is the difference between the Gross enrolment ratio (%) in Pre-primary schools in 2007 and the Gross enrolment ratio (%) in Secondary schools in 2008?
Ensure brevity in your answer.  -70.59. What is the difference between the Gross enrolment ratio (%) of Pre-primary schools in 2007 and the Gross enrolment ratio (%) of Tertiary schools in 2008?
Provide a short and direct response. -14.73. What is the difference between the Gross enrolment ratio (%) in Primary schools in 2007 and the Gross enrolment ratio (%) in Secondary schools in 2008?
Offer a very short reply. 17.34. What is the difference between the Gross enrolment ratio (%) in Primary schools in 2007 and the Gross enrolment ratio (%) in Tertiary schools in 2008?
Give a very brief answer. 73.2. What is the difference between the Gross enrolment ratio (%) in Secondary schools in 2007 and the Gross enrolment ratio (%) in Tertiary schools in 2008?
Your answer should be compact. 53.58. What is the difference between the Gross enrolment ratio (%) in Pre-primary schools in 2007 and the Gross enrolment ratio (%) in Primary schools in 2009?
Offer a terse response. -72.53. What is the difference between the Gross enrolment ratio (%) in Pre-primary schools in 2007 and the Gross enrolment ratio (%) in Secondary schools in 2009?
Offer a terse response. -63.06. What is the difference between the Gross enrolment ratio (%) of Pre-primary schools in 2007 and the Gross enrolment ratio (%) of Tertiary schools in 2009?
Offer a terse response. -23.81. What is the difference between the Gross enrolment ratio (%) in Primary schools in 2007 and the Gross enrolment ratio (%) in Secondary schools in 2009?
Your answer should be very brief. 24.87. What is the difference between the Gross enrolment ratio (%) of Primary schools in 2007 and the Gross enrolment ratio (%) of Tertiary schools in 2009?
Make the answer very short. 64.13. What is the difference between the Gross enrolment ratio (%) in Secondary schools in 2007 and the Gross enrolment ratio (%) in Tertiary schools in 2009?
Your answer should be compact. 44.5. What is the difference between the Gross enrolment ratio (%) in Pre-primary schools in 2007 and the Gross enrolment ratio (%) in Primary schools in 2010?
Make the answer very short. -72.97. What is the difference between the Gross enrolment ratio (%) of Pre-primary schools in 2007 and the Gross enrolment ratio (%) of Secondary schools in 2010?
Your response must be concise. -62.92. What is the difference between the Gross enrolment ratio (%) of Pre-primary schools in 2007 and the Gross enrolment ratio (%) of Tertiary schools in 2010?
Ensure brevity in your answer.  -27.55. What is the difference between the Gross enrolment ratio (%) in Primary schools in 2007 and the Gross enrolment ratio (%) in Secondary schools in 2010?
Provide a short and direct response. 25.01. What is the difference between the Gross enrolment ratio (%) in Primary schools in 2007 and the Gross enrolment ratio (%) in Tertiary schools in 2010?
Provide a succinct answer. 60.38. What is the difference between the Gross enrolment ratio (%) in Secondary schools in 2007 and the Gross enrolment ratio (%) in Tertiary schools in 2010?
Provide a short and direct response. 40.76. What is the difference between the Gross enrolment ratio (%) in Pre-primary schools in 2008 and the Gross enrolment ratio (%) in Primary schools in 2009?
Provide a succinct answer. -70.75. What is the difference between the Gross enrolment ratio (%) in Pre-primary schools in 2008 and the Gross enrolment ratio (%) in Secondary schools in 2009?
Your answer should be compact. -61.28. What is the difference between the Gross enrolment ratio (%) of Pre-primary schools in 2008 and the Gross enrolment ratio (%) of Tertiary schools in 2009?
Offer a very short reply. -22.03. What is the difference between the Gross enrolment ratio (%) of Primary schools in 2008 and the Gross enrolment ratio (%) of Secondary schools in 2009?
Provide a succinct answer. 20.11. What is the difference between the Gross enrolment ratio (%) in Primary schools in 2008 and the Gross enrolment ratio (%) in Tertiary schools in 2009?
Your answer should be very brief. 59.37. What is the difference between the Gross enrolment ratio (%) of Secondary schools in 2008 and the Gross enrolment ratio (%) of Tertiary schools in 2009?
Offer a very short reply. 46.79. What is the difference between the Gross enrolment ratio (%) in Pre-primary schools in 2008 and the Gross enrolment ratio (%) in Primary schools in 2010?
Provide a succinct answer. -71.19. What is the difference between the Gross enrolment ratio (%) of Pre-primary schools in 2008 and the Gross enrolment ratio (%) of Secondary schools in 2010?
Make the answer very short. -61.15. What is the difference between the Gross enrolment ratio (%) of Pre-primary schools in 2008 and the Gross enrolment ratio (%) of Tertiary schools in 2010?
Your response must be concise. -25.77. What is the difference between the Gross enrolment ratio (%) in Primary schools in 2008 and the Gross enrolment ratio (%) in Secondary schools in 2010?
Provide a short and direct response. 20.25. What is the difference between the Gross enrolment ratio (%) in Primary schools in 2008 and the Gross enrolment ratio (%) in Tertiary schools in 2010?
Ensure brevity in your answer.  55.62. What is the difference between the Gross enrolment ratio (%) of Secondary schools in 2008 and the Gross enrolment ratio (%) of Tertiary schools in 2010?
Provide a short and direct response. 43.04. What is the difference between the Gross enrolment ratio (%) in Pre-primary schools in 2009 and the Gross enrolment ratio (%) in Primary schools in 2010?
Keep it short and to the point. -69.33. What is the difference between the Gross enrolment ratio (%) in Pre-primary schools in 2009 and the Gross enrolment ratio (%) in Secondary schools in 2010?
Offer a very short reply. -59.29. What is the difference between the Gross enrolment ratio (%) of Pre-primary schools in 2009 and the Gross enrolment ratio (%) of Tertiary schools in 2010?
Ensure brevity in your answer.  -23.91. What is the difference between the Gross enrolment ratio (%) of Primary schools in 2009 and the Gross enrolment ratio (%) of Secondary schools in 2010?
Your answer should be very brief. 9.6. What is the difference between the Gross enrolment ratio (%) in Primary schools in 2009 and the Gross enrolment ratio (%) in Tertiary schools in 2010?
Provide a succinct answer. 44.97. What is the difference between the Gross enrolment ratio (%) in Secondary schools in 2009 and the Gross enrolment ratio (%) in Tertiary schools in 2010?
Your response must be concise. 35.51. What is the average Gross enrolment ratio (%) of Pre-primary schools per year?
Your answer should be compact. 31.84. What is the average Gross enrolment ratio (%) in Primary schools per year?
Offer a very short reply. 111.96. What is the average Gross enrolment ratio (%) in Secondary schools per year?
Provide a succinct answer. 94.38. What is the average Gross enrolment ratio (%) in Tertiary schools per year?
Offer a terse response. 33.82. In the year 2003, what is the difference between the Gross enrolment ratio (%) of Pre-primary schools and Gross enrolment ratio (%) of Primary schools?
Provide a succinct answer. -75.98. In the year 2003, what is the difference between the Gross enrolment ratio (%) in Pre-primary schools and Gross enrolment ratio (%) in Secondary schools?
Keep it short and to the point. -59.8. In the year 2003, what is the difference between the Gross enrolment ratio (%) of Pre-primary schools and Gross enrolment ratio (%) of Tertiary schools?
Make the answer very short. 17.64. In the year 2003, what is the difference between the Gross enrolment ratio (%) of Primary schools and Gross enrolment ratio (%) of Secondary schools?
Your answer should be compact. 16.18. In the year 2003, what is the difference between the Gross enrolment ratio (%) in Primary schools and Gross enrolment ratio (%) in Tertiary schools?
Your response must be concise. 93.62. In the year 2003, what is the difference between the Gross enrolment ratio (%) in Secondary schools and Gross enrolment ratio (%) in Tertiary schools?
Provide a succinct answer. 77.45. In the year 2004, what is the difference between the Gross enrolment ratio (%) in Pre-primary schools and Gross enrolment ratio (%) in Primary schools?
Your response must be concise. -82.87. In the year 2004, what is the difference between the Gross enrolment ratio (%) in Pre-primary schools and Gross enrolment ratio (%) in Secondary schools?
Provide a succinct answer. -61.43. In the year 2004, what is the difference between the Gross enrolment ratio (%) in Pre-primary schools and Gross enrolment ratio (%) in Tertiary schools?
Provide a succinct answer. 13.42. In the year 2004, what is the difference between the Gross enrolment ratio (%) in Primary schools and Gross enrolment ratio (%) in Secondary schools?
Your answer should be compact. 21.44. In the year 2004, what is the difference between the Gross enrolment ratio (%) of Primary schools and Gross enrolment ratio (%) of Tertiary schools?
Keep it short and to the point. 96.29. In the year 2004, what is the difference between the Gross enrolment ratio (%) of Secondary schools and Gross enrolment ratio (%) of Tertiary schools?
Make the answer very short. 74.85. In the year 2005, what is the difference between the Gross enrolment ratio (%) of Pre-primary schools and Gross enrolment ratio (%) of Primary schools?
Your answer should be compact. -86.13. In the year 2005, what is the difference between the Gross enrolment ratio (%) of Pre-primary schools and Gross enrolment ratio (%) of Secondary schools?
Ensure brevity in your answer.  -62.07. In the year 2005, what is the difference between the Gross enrolment ratio (%) of Pre-primary schools and Gross enrolment ratio (%) of Tertiary schools?
Ensure brevity in your answer.  10.2. In the year 2005, what is the difference between the Gross enrolment ratio (%) in Primary schools and Gross enrolment ratio (%) in Secondary schools?
Give a very brief answer. 24.06. In the year 2005, what is the difference between the Gross enrolment ratio (%) of Primary schools and Gross enrolment ratio (%) of Tertiary schools?
Provide a short and direct response. 96.33. In the year 2005, what is the difference between the Gross enrolment ratio (%) of Secondary schools and Gross enrolment ratio (%) of Tertiary schools?
Offer a very short reply. 72.27. In the year 2006, what is the difference between the Gross enrolment ratio (%) in Pre-primary schools and Gross enrolment ratio (%) in Primary schools?
Provide a succinct answer. -89.54. In the year 2006, what is the difference between the Gross enrolment ratio (%) in Pre-primary schools and Gross enrolment ratio (%) in Secondary schools?
Give a very brief answer. -62.32. In the year 2006, what is the difference between the Gross enrolment ratio (%) in Pre-primary schools and Gross enrolment ratio (%) in Tertiary schools?
Keep it short and to the point. 5.28. In the year 2006, what is the difference between the Gross enrolment ratio (%) of Primary schools and Gross enrolment ratio (%) of Secondary schools?
Give a very brief answer. 27.23. In the year 2006, what is the difference between the Gross enrolment ratio (%) in Primary schools and Gross enrolment ratio (%) in Tertiary schools?
Make the answer very short. 94.82. In the year 2006, what is the difference between the Gross enrolment ratio (%) in Secondary schools and Gross enrolment ratio (%) in Tertiary schools?
Give a very brief answer. 67.59. In the year 2007, what is the difference between the Gross enrolment ratio (%) of Pre-primary schools and Gross enrolment ratio (%) of Primary schools?
Your response must be concise. -87.93. In the year 2007, what is the difference between the Gross enrolment ratio (%) in Pre-primary schools and Gross enrolment ratio (%) in Secondary schools?
Offer a very short reply. -68.31. In the year 2007, what is the difference between the Gross enrolment ratio (%) in Pre-primary schools and Gross enrolment ratio (%) in Tertiary schools?
Offer a terse response. -6.49. In the year 2007, what is the difference between the Gross enrolment ratio (%) of Primary schools and Gross enrolment ratio (%) of Secondary schools?
Keep it short and to the point. 19.62. In the year 2007, what is the difference between the Gross enrolment ratio (%) of Primary schools and Gross enrolment ratio (%) of Tertiary schools?
Provide a succinct answer. 81.45. In the year 2007, what is the difference between the Gross enrolment ratio (%) of Secondary schools and Gross enrolment ratio (%) of Tertiary schools?
Your response must be concise. 61.83. In the year 2008, what is the difference between the Gross enrolment ratio (%) in Pre-primary schools and Gross enrolment ratio (%) in Primary schools?
Keep it short and to the point. -81.4. In the year 2008, what is the difference between the Gross enrolment ratio (%) of Pre-primary schools and Gross enrolment ratio (%) of Secondary schools?
Offer a very short reply. -68.81. In the year 2008, what is the difference between the Gross enrolment ratio (%) of Pre-primary schools and Gross enrolment ratio (%) of Tertiary schools?
Ensure brevity in your answer.  -12.95. In the year 2008, what is the difference between the Gross enrolment ratio (%) of Primary schools and Gross enrolment ratio (%) of Secondary schools?
Your answer should be compact. 12.58. In the year 2008, what is the difference between the Gross enrolment ratio (%) of Primary schools and Gross enrolment ratio (%) of Tertiary schools?
Make the answer very short. 68.45. In the year 2008, what is the difference between the Gross enrolment ratio (%) in Secondary schools and Gross enrolment ratio (%) in Tertiary schools?
Your answer should be compact. 55.86. In the year 2009, what is the difference between the Gross enrolment ratio (%) in Pre-primary schools and Gross enrolment ratio (%) in Primary schools?
Keep it short and to the point. -68.89. In the year 2009, what is the difference between the Gross enrolment ratio (%) in Pre-primary schools and Gross enrolment ratio (%) in Secondary schools?
Give a very brief answer. -59.42. In the year 2009, what is the difference between the Gross enrolment ratio (%) of Pre-primary schools and Gross enrolment ratio (%) of Tertiary schools?
Ensure brevity in your answer.  -20.17. In the year 2009, what is the difference between the Gross enrolment ratio (%) of Primary schools and Gross enrolment ratio (%) of Secondary schools?
Offer a terse response. 9.46. In the year 2009, what is the difference between the Gross enrolment ratio (%) in Primary schools and Gross enrolment ratio (%) in Tertiary schools?
Provide a short and direct response. 48.72. In the year 2009, what is the difference between the Gross enrolment ratio (%) in Secondary schools and Gross enrolment ratio (%) in Tertiary schools?
Your response must be concise. 39.26. In the year 2010, what is the difference between the Gross enrolment ratio (%) in Pre-primary schools and Gross enrolment ratio (%) in Primary schools?
Offer a terse response. -68.2. In the year 2010, what is the difference between the Gross enrolment ratio (%) in Pre-primary schools and Gross enrolment ratio (%) in Secondary schools?
Make the answer very short. -58.15. In the year 2010, what is the difference between the Gross enrolment ratio (%) of Pre-primary schools and Gross enrolment ratio (%) of Tertiary schools?
Provide a succinct answer. -22.78. In the year 2010, what is the difference between the Gross enrolment ratio (%) in Primary schools and Gross enrolment ratio (%) in Secondary schools?
Ensure brevity in your answer.  10.04. In the year 2010, what is the difference between the Gross enrolment ratio (%) of Primary schools and Gross enrolment ratio (%) of Tertiary schools?
Provide a succinct answer. 45.42. In the year 2010, what is the difference between the Gross enrolment ratio (%) in Secondary schools and Gross enrolment ratio (%) in Tertiary schools?
Keep it short and to the point. 35.37. What is the ratio of the Gross enrolment ratio (%) in Pre-primary schools in 2003 to that in 2004?
Provide a short and direct response. 1.04. What is the ratio of the Gross enrolment ratio (%) of Primary schools in 2003 to that in 2004?
Keep it short and to the point. 0.95. What is the ratio of the Gross enrolment ratio (%) in Tertiary schools in 2003 to that in 2004?
Ensure brevity in your answer.  0.85. What is the ratio of the Gross enrolment ratio (%) of Pre-primary schools in 2003 to that in 2005?
Your answer should be very brief. 1.05. What is the ratio of the Gross enrolment ratio (%) in Primary schools in 2003 to that in 2005?
Ensure brevity in your answer.  0.93. What is the ratio of the Gross enrolment ratio (%) of Secondary schools in 2003 to that in 2005?
Give a very brief answer. 0.99. What is the ratio of the Gross enrolment ratio (%) in Tertiary schools in 2003 to that in 2005?
Make the answer very short. 0.75. What is the ratio of the Gross enrolment ratio (%) in Pre-primary schools in 2003 to that in 2006?
Offer a terse response. 1.07. What is the ratio of the Gross enrolment ratio (%) of Primary schools in 2003 to that in 2006?
Make the answer very short. 0.91. What is the ratio of the Gross enrolment ratio (%) in Secondary schools in 2003 to that in 2006?
Provide a short and direct response. 1. What is the ratio of the Gross enrolment ratio (%) of Tertiary schools in 2003 to that in 2006?
Provide a short and direct response. 0.63. What is the ratio of the Gross enrolment ratio (%) of Pre-primary schools in 2003 to that in 2007?
Offer a very short reply. 1.23. What is the ratio of the Gross enrolment ratio (%) in Primary schools in 2003 to that in 2007?
Ensure brevity in your answer.  0.95. What is the ratio of the Gross enrolment ratio (%) in Secondary schools in 2003 to that in 2007?
Give a very brief answer. 0.98. What is the ratio of the Gross enrolment ratio (%) of Tertiary schools in 2003 to that in 2007?
Offer a terse response. 0.49. What is the ratio of the Gross enrolment ratio (%) in Pre-primary schools in 2003 to that in 2008?
Your answer should be compact. 1.16. What is the ratio of the Gross enrolment ratio (%) in Secondary schools in 2003 to that in 2008?
Ensure brevity in your answer.  0.96. What is the ratio of the Gross enrolment ratio (%) in Tertiary schools in 2003 to that in 2008?
Offer a terse response. 0.39. What is the ratio of the Gross enrolment ratio (%) in Pre-primary schools in 2003 to that in 2009?
Your answer should be very brief. 1.09. What is the ratio of the Gross enrolment ratio (%) of Primary schools in 2003 to that in 2009?
Make the answer very short. 1.1. What is the ratio of the Gross enrolment ratio (%) in Secondary schools in 2003 to that in 2009?
Your answer should be compact. 1.04. What is the ratio of the Gross enrolment ratio (%) of Tertiary schools in 2003 to that in 2009?
Offer a very short reply. 0.33. What is the ratio of the Gross enrolment ratio (%) in Pre-primary schools in 2003 to that in 2010?
Your response must be concise. 1.05. What is the ratio of the Gross enrolment ratio (%) in Primary schools in 2003 to that in 2010?
Your answer should be compact. 1.09. What is the ratio of the Gross enrolment ratio (%) in Secondary schools in 2003 to that in 2010?
Your answer should be very brief. 1.04. What is the ratio of the Gross enrolment ratio (%) of Tertiary schools in 2003 to that in 2010?
Offer a very short reply. 0.3. What is the ratio of the Gross enrolment ratio (%) in Pre-primary schools in 2004 to that in 2005?
Your response must be concise. 1.01. What is the ratio of the Gross enrolment ratio (%) of Primary schools in 2004 to that in 2005?
Provide a short and direct response. 0.98. What is the ratio of the Gross enrolment ratio (%) of Secondary schools in 2004 to that in 2005?
Keep it short and to the point. 1. What is the ratio of the Gross enrolment ratio (%) of Tertiary schools in 2004 to that in 2005?
Offer a terse response. 0.88. What is the ratio of the Gross enrolment ratio (%) of Pre-primary schools in 2004 to that in 2006?
Your answer should be very brief. 1.03. What is the ratio of the Gross enrolment ratio (%) in Primary schools in 2004 to that in 2006?
Offer a terse response. 0.95. What is the ratio of the Gross enrolment ratio (%) of Secondary schools in 2004 to that in 2006?
Ensure brevity in your answer.  1. What is the ratio of the Gross enrolment ratio (%) of Tertiary schools in 2004 to that in 2006?
Make the answer very short. 0.74. What is the ratio of the Gross enrolment ratio (%) in Pre-primary schools in 2004 to that in 2007?
Offer a very short reply. 1.19. What is the ratio of the Gross enrolment ratio (%) of Secondary schools in 2004 to that in 2007?
Make the answer very short. 0.98. What is the ratio of the Gross enrolment ratio (%) of Tertiary schools in 2004 to that in 2007?
Your answer should be compact. 0.58. What is the ratio of the Gross enrolment ratio (%) in Pre-primary schools in 2004 to that in 2008?
Provide a succinct answer. 1.12. What is the ratio of the Gross enrolment ratio (%) of Primary schools in 2004 to that in 2008?
Give a very brief answer. 1.04. What is the ratio of the Gross enrolment ratio (%) of Secondary schools in 2004 to that in 2008?
Make the answer very short. 0.96. What is the ratio of the Gross enrolment ratio (%) of Tertiary schools in 2004 to that in 2008?
Keep it short and to the point. 0.46. What is the ratio of the Gross enrolment ratio (%) in Pre-primary schools in 2004 to that in 2009?
Make the answer very short. 1.05. What is the ratio of the Gross enrolment ratio (%) in Primary schools in 2004 to that in 2009?
Offer a terse response. 1.16. What is the ratio of the Gross enrolment ratio (%) in Secondary schools in 2004 to that in 2009?
Your answer should be very brief. 1.04. What is the ratio of the Gross enrolment ratio (%) in Tertiary schools in 2004 to that in 2009?
Provide a short and direct response. 0.38. What is the ratio of the Gross enrolment ratio (%) in Pre-primary schools in 2004 to that in 2010?
Keep it short and to the point. 1.01. What is the ratio of the Gross enrolment ratio (%) in Primary schools in 2004 to that in 2010?
Your response must be concise. 1.15. What is the ratio of the Gross enrolment ratio (%) of Secondary schools in 2004 to that in 2010?
Provide a short and direct response. 1.04. What is the ratio of the Gross enrolment ratio (%) in Tertiary schools in 2004 to that in 2010?
Give a very brief answer. 0.36. What is the ratio of the Gross enrolment ratio (%) in Pre-primary schools in 2005 to that in 2006?
Offer a terse response. 1.02. What is the ratio of the Gross enrolment ratio (%) in Primary schools in 2005 to that in 2006?
Give a very brief answer. 0.98. What is the ratio of the Gross enrolment ratio (%) of Secondary schools in 2005 to that in 2006?
Give a very brief answer. 1. What is the ratio of the Gross enrolment ratio (%) of Tertiary schools in 2005 to that in 2006?
Ensure brevity in your answer.  0.84. What is the ratio of the Gross enrolment ratio (%) in Pre-primary schools in 2005 to that in 2007?
Give a very brief answer. 1.17. What is the ratio of the Gross enrolment ratio (%) of Primary schools in 2005 to that in 2007?
Offer a terse response. 1.03. What is the ratio of the Gross enrolment ratio (%) in Tertiary schools in 2005 to that in 2007?
Provide a short and direct response. 0.65. What is the ratio of the Gross enrolment ratio (%) in Pre-primary schools in 2005 to that in 2008?
Provide a short and direct response. 1.1. What is the ratio of the Gross enrolment ratio (%) of Primary schools in 2005 to that in 2008?
Provide a succinct answer. 1.07. What is the ratio of the Gross enrolment ratio (%) of Secondary schools in 2005 to that in 2008?
Offer a terse response. 0.96. What is the ratio of the Gross enrolment ratio (%) of Tertiary schools in 2005 to that in 2008?
Offer a very short reply. 0.53. What is the ratio of the Gross enrolment ratio (%) of Pre-primary schools in 2005 to that in 2009?
Your answer should be compact. 1.04. What is the ratio of the Gross enrolment ratio (%) in Primary schools in 2005 to that in 2009?
Your answer should be compact. 1.18. What is the ratio of the Gross enrolment ratio (%) of Secondary schools in 2005 to that in 2009?
Keep it short and to the point. 1.04. What is the ratio of the Gross enrolment ratio (%) in Tertiary schools in 2005 to that in 2009?
Keep it short and to the point. 0.44. What is the ratio of the Gross enrolment ratio (%) of Pre-primary schools in 2005 to that in 2010?
Offer a very short reply. 1. What is the ratio of the Gross enrolment ratio (%) of Primary schools in 2005 to that in 2010?
Make the answer very short. 1.18. What is the ratio of the Gross enrolment ratio (%) of Secondary schools in 2005 to that in 2010?
Give a very brief answer. 1.04. What is the ratio of the Gross enrolment ratio (%) of Tertiary schools in 2005 to that in 2010?
Provide a short and direct response. 0.41. What is the ratio of the Gross enrolment ratio (%) of Pre-primary schools in 2006 to that in 2007?
Keep it short and to the point. 1.15. What is the ratio of the Gross enrolment ratio (%) in Primary schools in 2006 to that in 2007?
Provide a short and direct response. 1.05. What is the ratio of the Gross enrolment ratio (%) of Secondary schools in 2006 to that in 2007?
Provide a short and direct response. 0.98. What is the ratio of the Gross enrolment ratio (%) in Tertiary schools in 2006 to that in 2007?
Make the answer very short. 0.78. What is the ratio of the Gross enrolment ratio (%) of Pre-primary schools in 2006 to that in 2008?
Your answer should be very brief. 1.08. What is the ratio of the Gross enrolment ratio (%) in Primary schools in 2006 to that in 2008?
Make the answer very short. 1.09. What is the ratio of the Gross enrolment ratio (%) of Secondary schools in 2006 to that in 2008?
Provide a succinct answer. 0.96. What is the ratio of the Gross enrolment ratio (%) of Tertiary schools in 2006 to that in 2008?
Offer a very short reply. 0.63. What is the ratio of the Gross enrolment ratio (%) in Pre-primary schools in 2006 to that in 2009?
Provide a succinct answer. 1.02. What is the ratio of the Gross enrolment ratio (%) in Primary schools in 2006 to that in 2009?
Your response must be concise. 1.21. What is the ratio of the Gross enrolment ratio (%) of Secondary schools in 2006 to that in 2009?
Offer a terse response. 1.04. What is the ratio of the Gross enrolment ratio (%) in Tertiary schools in 2006 to that in 2009?
Ensure brevity in your answer.  0.52. What is the ratio of the Gross enrolment ratio (%) of Pre-primary schools in 2006 to that in 2010?
Your response must be concise. 0.98. What is the ratio of the Gross enrolment ratio (%) of Primary schools in 2006 to that in 2010?
Provide a succinct answer. 1.21. What is the ratio of the Gross enrolment ratio (%) in Secondary schools in 2006 to that in 2010?
Your answer should be compact. 1.04. What is the ratio of the Gross enrolment ratio (%) of Tertiary schools in 2006 to that in 2010?
Ensure brevity in your answer.  0.48. What is the ratio of the Gross enrolment ratio (%) of Pre-primary schools in 2007 to that in 2008?
Your answer should be very brief. 0.94. What is the ratio of the Gross enrolment ratio (%) in Primary schools in 2007 to that in 2008?
Your answer should be compact. 1.04. What is the ratio of the Gross enrolment ratio (%) of Secondary schools in 2007 to that in 2008?
Provide a succinct answer. 0.98. What is the ratio of the Gross enrolment ratio (%) of Tertiary schools in 2007 to that in 2008?
Provide a short and direct response. 0.81. What is the ratio of the Gross enrolment ratio (%) in Pre-primary schools in 2007 to that in 2009?
Your response must be concise. 0.88. What is the ratio of the Gross enrolment ratio (%) in Primary schools in 2007 to that in 2009?
Provide a succinct answer. 1.15. What is the ratio of the Gross enrolment ratio (%) in Secondary schools in 2007 to that in 2009?
Provide a short and direct response. 1.06. What is the ratio of the Gross enrolment ratio (%) of Tertiary schools in 2007 to that in 2009?
Your answer should be very brief. 0.67. What is the ratio of the Gross enrolment ratio (%) of Pre-primary schools in 2007 to that in 2010?
Keep it short and to the point. 0.85. What is the ratio of the Gross enrolment ratio (%) of Primary schools in 2007 to that in 2010?
Give a very brief answer. 1.15. What is the ratio of the Gross enrolment ratio (%) of Secondary schools in 2007 to that in 2010?
Keep it short and to the point. 1.06. What is the ratio of the Gross enrolment ratio (%) in Tertiary schools in 2007 to that in 2010?
Provide a succinct answer. 0.62. What is the ratio of the Gross enrolment ratio (%) in Pre-primary schools in 2008 to that in 2009?
Provide a succinct answer. 0.94. What is the ratio of the Gross enrolment ratio (%) in Primary schools in 2008 to that in 2009?
Offer a terse response. 1.11. What is the ratio of the Gross enrolment ratio (%) of Secondary schools in 2008 to that in 2009?
Provide a succinct answer. 1.08. What is the ratio of the Gross enrolment ratio (%) of Tertiary schools in 2008 to that in 2009?
Your answer should be very brief. 0.82. What is the ratio of the Gross enrolment ratio (%) of Pre-primary schools in 2008 to that in 2010?
Provide a short and direct response. 0.91. What is the ratio of the Gross enrolment ratio (%) of Primary schools in 2008 to that in 2010?
Offer a very short reply. 1.1. What is the ratio of the Gross enrolment ratio (%) of Secondary schools in 2008 to that in 2010?
Offer a terse response. 1.08. What is the ratio of the Gross enrolment ratio (%) of Tertiary schools in 2008 to that in 2010?
Your answer should be compact. 0.77. What is the ratio of the Gross enrolment ratio (%) in Pre-primary schools in 2009 to that in 2010?
Give a very brief answer. 0.97. What is the ratio of the Gross enrolment ratio (%) of Primary schools in 2009 to that in 2010?
Provide a succinct answer. 1. What is the ratio of the Gross enrolment ratio (%) of Secondary schools in 2009 to that in 2010?
Keep it short and to the point. 1. What is the ratio of the Gross enrolment ratio (%) in Tertiary schools in 2009 to that in 2010?
Your response must be concise. 0.93. What is the difference between the highest and the second highest Gross enrolment ratio (%) of Pre-primary schools?
Your answer should be compact. 1.25. What is the difference between the highest and the second highest Gross enrolment ratio (%) in Primary schools?
Provide a succinct answer. 2.76. What is the difference between the highest and the second highest Gross enrolment ratio (%) in Secondary schools?
Ensure brevity in your answer.  2.28. What is the difference between the highest and the second highest Gross enrolment ratio (%) of Tertiary schools?
Ensure brevity in your answer.  3.75. What is the difference between the highest and the lowest Gross enrolment ratio (%) in Pre-primary schools?
Provide a short and direct response. 6.51. What is the difference between the highest and the lowest Gross enrolment ratio (%) in Primary schools?
Your response must be concise. 21.16. What is the difference between the highest and the lowest Gross enrolment ratio (%) of Secondary schools?
Provide a succinct answer. 7.67. What is the difference between the highest and the lowest Gross enrolment ratio (%) of Tertiary schools?
Offer a very short reply. 38.69. 